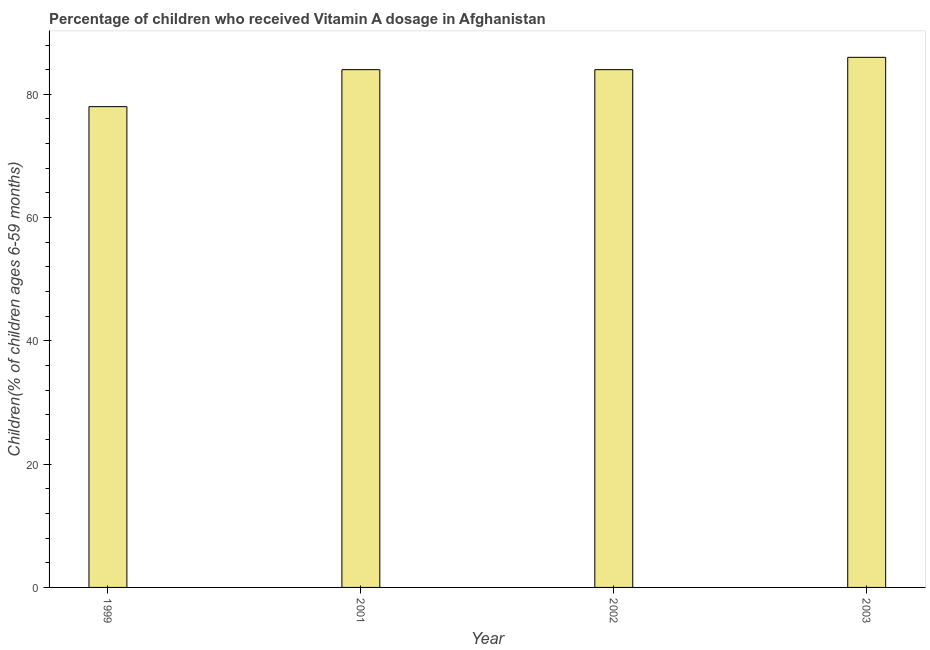Does the graph contain grids?
Your answer should be very brief. No. What is the title of the graph?
Give a very brief answer. Percentage of children who received Vitamin A dosage in Afghanistan. What is the label or title of the X-axis?
Offer a very short reply. Year. What is the label or title of the Y-axis?
Your answer should be very brief. Children(% of children ages 6-59 months). What is the vitamin a supplementation coverage rate in 2002?
Make the answer very short. 84. Across all years, what is the minimum vitamin a supplementation coverage rate?
Offer a terse response. 78. In which year was the vitamin a supplementation coverage rate maximum?
Give a very brief answer. 2003. In which year was the vitamin a supplementation coverage rate minimum?
Your answer should be compact. 1999. What is the sum of the vitamin a supplementation coverage rate?
Offer a terse response. 332. What is the difference between the vitamin a supplementation coverage rate in 1999 and 2003?
Provide a short and direct response. -8. What is the average vitamin a supplementation coverage rate per year?
Keep it short and to the point. 83. In how many years, is the vitamin a supplementation coverage rate greater than 64 %?
Provide a succinct answer. 4. What is the ratio of the vitamin a supplementation coverage rate in 1999 to that in 2003?
Ensure brevity in your answer.  0.91. Is the vitamin a supplementation coverage rate in 2001 less than that in 2002?
Offer a terse response. No. Is the sum of the vitamin a supplementation coverage rate in 1999 and 2003 greater than the maximum vitamin a supplementation coverage rate across all years?
Make the answer very short. Yes. What is the difference between the highest and the lowest vitamin a supplementation coverage rate?
Your answer should be compact. 8. What is the difference between two consecutive major ticks on the Y-axis?
Offer a very short reply. 20. What is the Children(% of children ages 6-59 months) in 1999?
Provide a short and direct response. 78. What is the Children(% of children ages 6-59 months) of 2002?
Ensure brevity in your answer.  84. What is the Children(% of children ages 6-59 months) in 2003?
Ensure brevity in your answer.  86. What is the difference between the Children(% of children ages 6-59 months) in 1999 and 2001?
Provide a succinct answer. -6. What is the difference between the Children(% of children ages 6-59 months) in 1999 and 2002?
Give a very brief answer. -6. What is the difference between the Children(% of children ages 6-59 months) in 1999 and 2003?
Your response must be concise. -8. What is the ratio of the Children(% of children ages 6-59 months) in 1999 to that in 2001?
Your answer should be compact. 0.93. What is the ratio of the Children(% of children ages 6-59 months) in 1999 to that in 2002?
Give a very brief answer. 0.93. What is the ratio of the Children(% of children ages 6-59 months) in 1999 to that in 2003?
Your answer should be very brief. 0.91. What is the ratio of the Children(% of children ages 6-59 months) in 2001 to that in 2002?
Your response must be concise. 1. What is the ratio of the Children(% of children ages 6-59 months) in 2002 to that in 2003?
Offer a terse response. 0.98. 